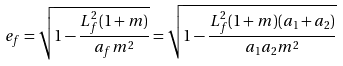Convert formula to latex. <formula><loc_0><loc_0><loc_500><loc_500>e _ { f } = \sqrt { 1 - \frac { L _ { f } ^ { 2 } ( 1 + m ) } { a _ { f } m ^ { 2 } } } = \sqrt { 1 - \frac { L _ { f } ^ { 2 } ( 1 + m ) ( a _ { 1 } + a _ { 2 } ) } { a _ { 1 } a _ { 2 } m ^ { 2 } } }</formula> 